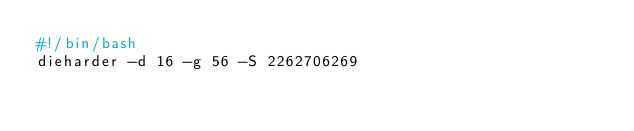Convert code to text. <code><loc_0><loc_0><loc_500><loc_500><_Bash_>#!/bin/bash
dieharder -d 16 -g 56 -S 2262706269
</code> 